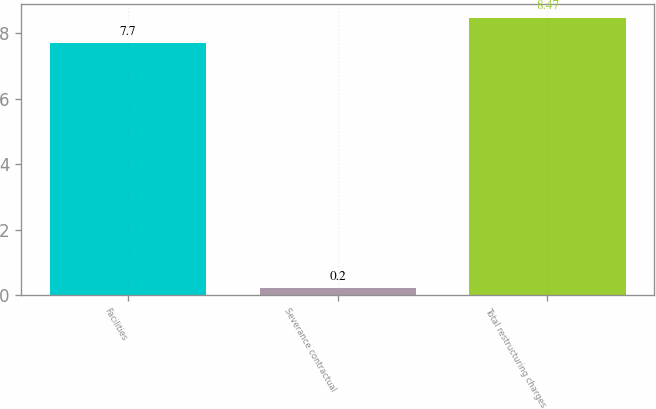Convert chart. <chart><loc_0><loc_0><loc_500><loc_500><bar_chart><fcel>Facilities<fcel>Severance contractual<fcel>Total restructuring charges<nl><fcel>7.7<fcel>0.2<fcel>8.47<nl></chart> 